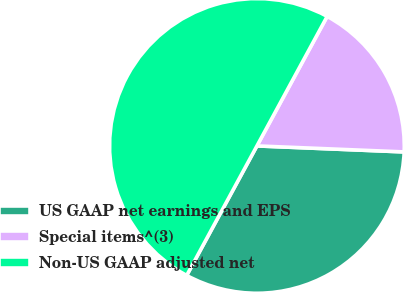Convert chart to OTSL. <chart><loc_0><loc_0><loc_500><loc_500><pie_chart><fcel>US GAAP net earnings and EPS<fcel>Special items^(3)<fcel>Non-US GAAP adjusted net<nl><fcel>32.26%<fcel>17.74%<fcel>50.0%<nl></chart> 